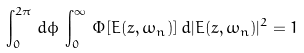Convert formula to latex. <formula><loc_0><loc_0><loc_500><loc_500>\int _ { 0 } ^ { 2 \pi } \, d \phi \, \int _ { 0 } ^ { \infty } \, \Phi [ E ( z , \omega _ { n } ) ] \, d | E ( z , \omega _ { n } ) | ^ { 2 } = 1</formula> 